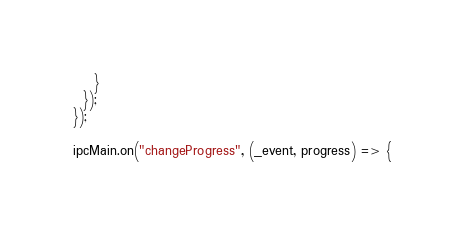Convert code to text. <code><loc_0><loc_0><loc_500><loc_500><_JavaScript_>    }
  });
});

ipcMain.on("changeProgress", (_event, progress) => {</code> 